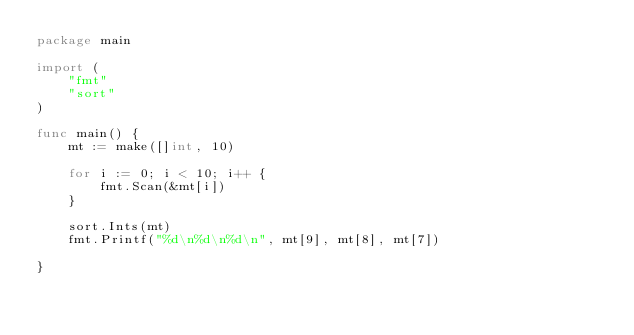<code> <loc_0><loc_0><loc_500><loc_500><_Go_>package main

import (
	"fmt"
	"sort"
)

func main() {
	mt := make([]int, 10)

	for i := 0; i < 10; i++ {
		fmt.Scan(&mt[i])
	}

	sort.Ints(mt)
	fmt.Printf("%d\n%d\n%d\n", mt[9], mt[8], mt[7])

}

</code> 